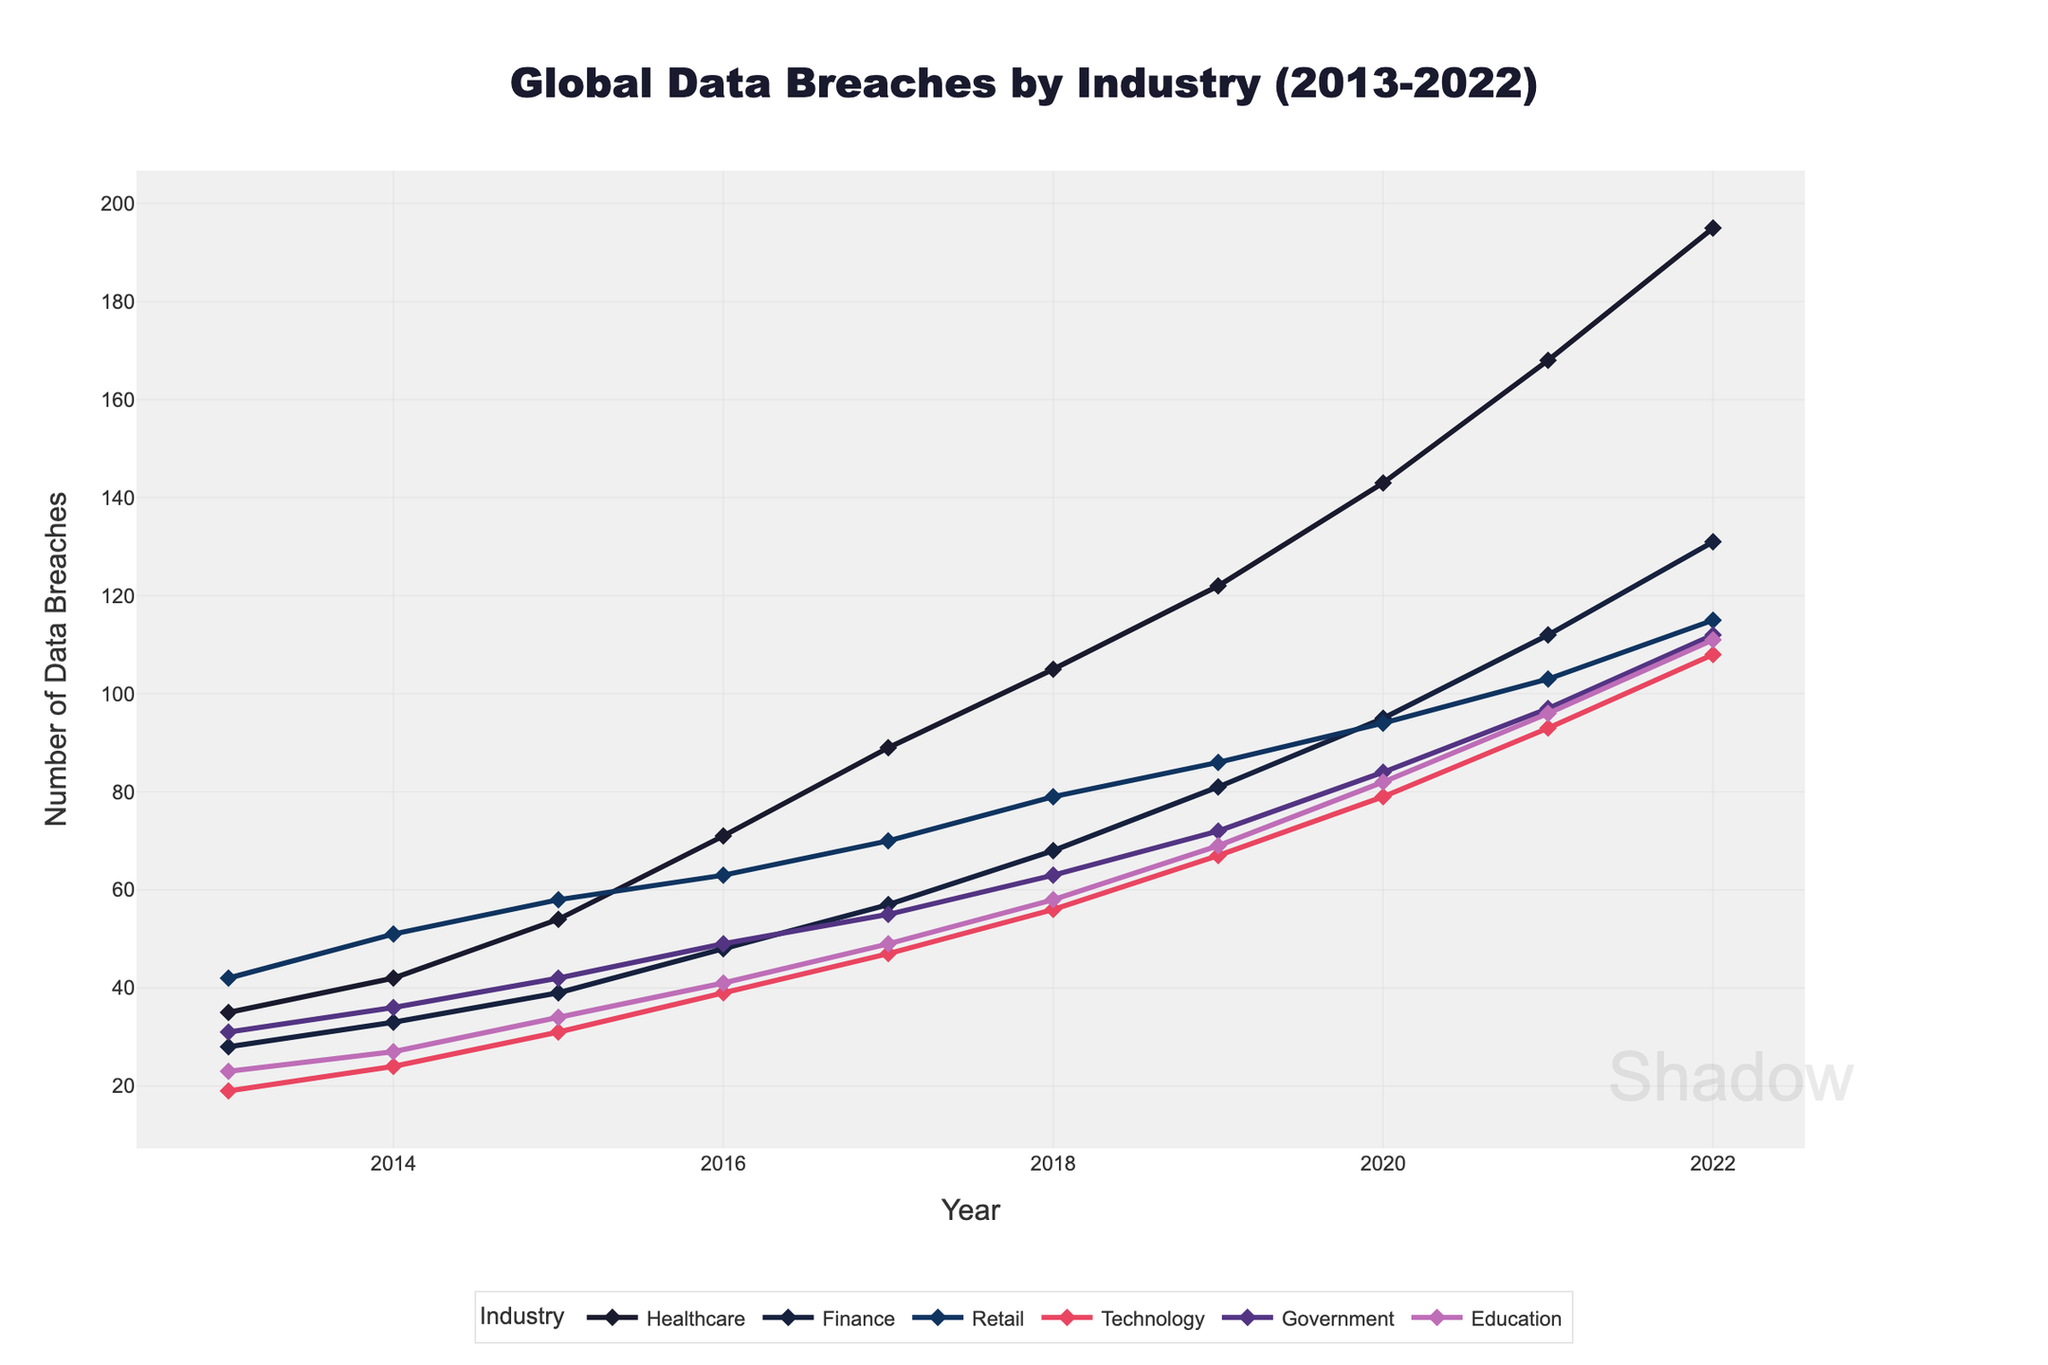Which industry experienced the highest number of data breaches in 2022? By observing the highest data point on the chart for the year 2022, we identify the industry with the maximum number of breaches. The Healthcare sector has the topmost point.
Answer: Healthcare How did the number of data breaches in the Government sector change from 2013 to 2022? Compare the height of the data points for the Government sector in 2013 and 2022. In 2013, the breaches were at 31, and in 2022, they increased to 112, indicating a rising trend.
Answer: Increased In which year did the Technology sector first surpass 50 data breaches? Identify the year when the line for the technology sector (red line) first crosses the 50-breach mark. This occurs between 2014 and 2015, in the year 2015.
Answer: 2015 What is the difference in the number of data breaches between Retail and Finance sectors in 2019? Observe the data points for Retail and Finance in 2019. The Retail sector has 86 breaches, and the Finance sector has 81 breaches. The difference is 86 - 81 = 5.
Answer: 5 Which industry had the smallest increase in data breaches from 2019 to 2022? Calculate the increase in data breaches for each sector from 2019 to 2022 and compare. For Education: 111-69=42, for Government: 112-72=40, for Technology: 108-67=41, for Retail: 115-86=29, for Finance: 131-81=50, for Healthcare: 195-122=73. Retail has the smallest increase with an increase of 29 breaches.
Answer: Retail What is the average number of data breaches in the Education sector over the decade? Summing the data breaches in the Education sector over the decade and dividing by the number of years: (23+27+34+41+49+58+69+82+96+111)/10 = 59.
Answer: 59 